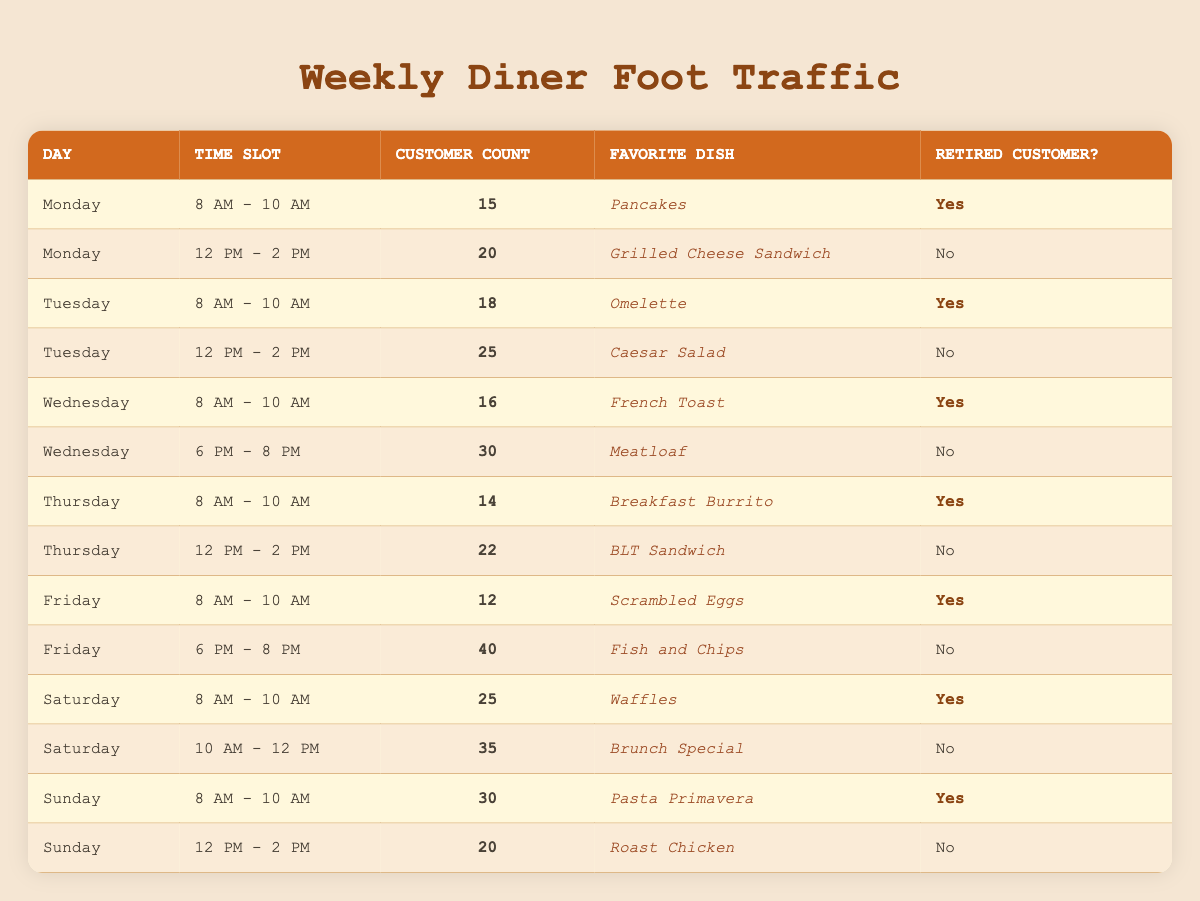What is the favorite dish of retired customers visiting on Wednesday at 8 AM? There is one entry for Wednesday at 8 AM in the table. The favorite dish listed for that time slot is French Toast, and the record indicates that the customer is indeed a retired customer.
Answer: French Toast How many customers visit the diner on Thursday from 12 PM to 2 PM? In the table, Thursday from 12 PM to 2 PM shows a customer count of 22.
Answer: 22 On which day do the highest number of retired customers come during the morning time slot (8 AM - 10 AM)? Examining the morning time slots for retired customers, the counts are: Monday (15), Tuesday (18), Wednesday (16), Thursday (14), Friday (12), Saturday (25), and Sunday (30). The day with the highest count is Sunday with 30 customers.
Answer: Sunday What is the total number of retired customers who visit during the 8 AM - 10 AM time slots across all days? The counts of retired customers during this time are: Monday (15), Tuesday (18), Wednesday (16), Thursday (14), Friday (12), Saturday (25), and Sunday (30). Summing these gives 15 + 18 + 16 + 14 + 12 + 25 + 30 = 130.
Answer: 130 Is the favorite dish of retired customers on Saturday from 8 AM - 10 AM pancakes? According to the table, the favorite dish for retired customers on Saturday at that time is Waffles, not pancakes. Therefore, the statement is false.
Answer: No How many retired customers visit during the week at the lunch time slots (12 PM - 2 PM)? In the table, the lunch time slots have no retired customers, since Monday, Tuesday, Wednesday, Thursday, Saturday, and Sunday all show "No" for retired customers. Thus, the total is 0.
Answer: 0 What is the average customer count during the 8 AM - 10 AM time slots for the days that have retired customers? We have the following customer counts for retired customers during that time: Monday (15), Tuesday (18), Wednesday (16), Thursday (14), Friday (12), Saturday (25), and Sunday (30), summing these gives 15 + 18 + 16 + 14 + 12 + 25 + 30 = 130 and there are 7 days, so the average is 130/7 ≈ 18.57.
Answer: 18.57 Which day has the least number of retired customers visiting the diner during the week? Looking at the customer counts for retired customers across the week: Monday (15), Tuesday (18), Wednesday (16), Thursday (14), Friday (12), Saturday (25), Sunday (30), Friday has the least count with 12.
Answer: Friday How many customer counts are there for non-retired customers on Sunday? On Sunday, the non-retired customer counts are 20 during the 12 PM to 2 PM slot. There are no other entries for non-retired customers on Sunday.
Answer: 20 